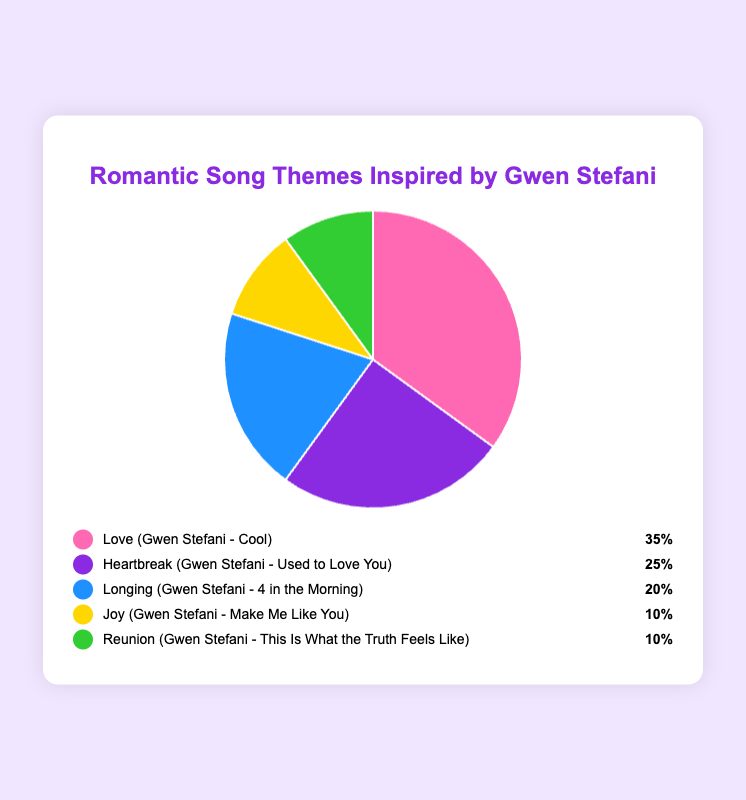What's the most common theme in romantic songs? From the pie chart, the largest segment represents the most common theme. The "Love" theme occupies the biggest portion of the pie chart with 35%.
Answer: Love How much percentage does "Heartbreak" and "Joy" together account for? The percentage of "Heartbreak" is 25% and "Joy" is 10%. Summing them up, 25% + 10% = 35%.
Answer: 35% Which theme has a smaller percentage, "Longing" or "Reunion"? "Longing" has a percentage of 20%, while "Reunion" has a percentage of 10%. Therefore, "Reunion" has a smaller percentage.
Answer: Reunion What is the total percentage of the themes inspired by Gwen Stefani's songs "Cool" and "Used to Love You"? The percentage for "Love" inspired by "Cool" is 35% and for "Heartbreak" inspired by "Used to Love You" is 25%. The total is 35% + 25% = 60%.
Answer: 60% If "Love" represents 35%, how much more does it have compared to "Joy"? "Love" has 35% while "Joy" has 10%. The difference is 35% - 10% = 25%.
Answer: 25% Which theme is associated with the song "4 in the Morning"? Referred to the pie chart and legend, the theme "Longing" is associated with the song "4 in the Morning".
Answer: Longing How many themes share an equal percentage in the chart? The legend shows that "Joy" and "Reunion" both share a percentage of 10%. Therefore, two themes share the same percentage.
Answer: 2 Which theme has a higher percentage, "Longing" or "Heartbreak"? The percentage of "Longing" is 20%, while "Heartbreak" has a percentage of 25%. Thus, "Heartbreak" has a higher percentage.
Answer: Heartbreak What is the average percentage of themes that make up less than 20%? The themes "Joy" and "Reunion" each have 10%, and only these two fall below 20%. Therefore, the average is (10% + 10%) / 2 = 10%.
Answer: 10% What color represents the "Heartbreak" theme on the chart? In the legend, the "Heartbreak" theme is represented by a purple color.
Answer: Purple 